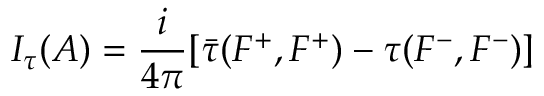<formula> <loc_0><loc_0><loc_500><loc_500>I _ { \tau } ( A ) = \frac { i } { 4 \pi } [ \bar { \tau } ( F ^ { + } , F ^ { + } ) - ( F ^ { - } , F ^ { - } ) ]</formula> 